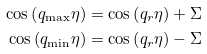<formula> <loc_0><loc_0><loc_500><loc_500>\cos \left ( q _ { \max } \eta \right ) = \cos \left ( q _ { r } \eta \right ) + \Sigma \\ \cos \left ( q _ { \min } \eta \right ) = \cos \left ( q _ { r } \eta \right ) - \Sigma</formula> 